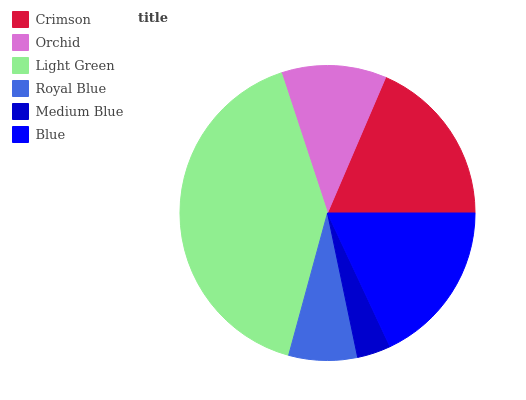Is Medium Blue the minimum?
Answer yes or no. Yes. Is Light Green the maximum?
Answer yes or no. Yes. Is Orchid the minimum?
Answer yes or no. No. Is Orchid the maximum?
Answer yes or no. No. Is Crimson greater than Orchid?
Answer yes or no. Yes. Is Orchid less than Crimson?
Answer yes or no. Yes. Is Orchid greater than Crimson?
Answer yes or no. No. Is Crimson less than Orchid?
Answer yes or no. No. Is Blue the high median?
Answer yes or no. Yes. Is Orchid the low median?
Answer yes or no. Yes. Is Light Green the high median?
Answer yes or no. No. Is Blue the low median?
Answer yes or no. No. 